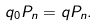Convert formula to latex. <formula><loc_0><loc_0><loc_500><loc_500>q _ { 0 } P _ { n } = q P _ { n } .</formula> 